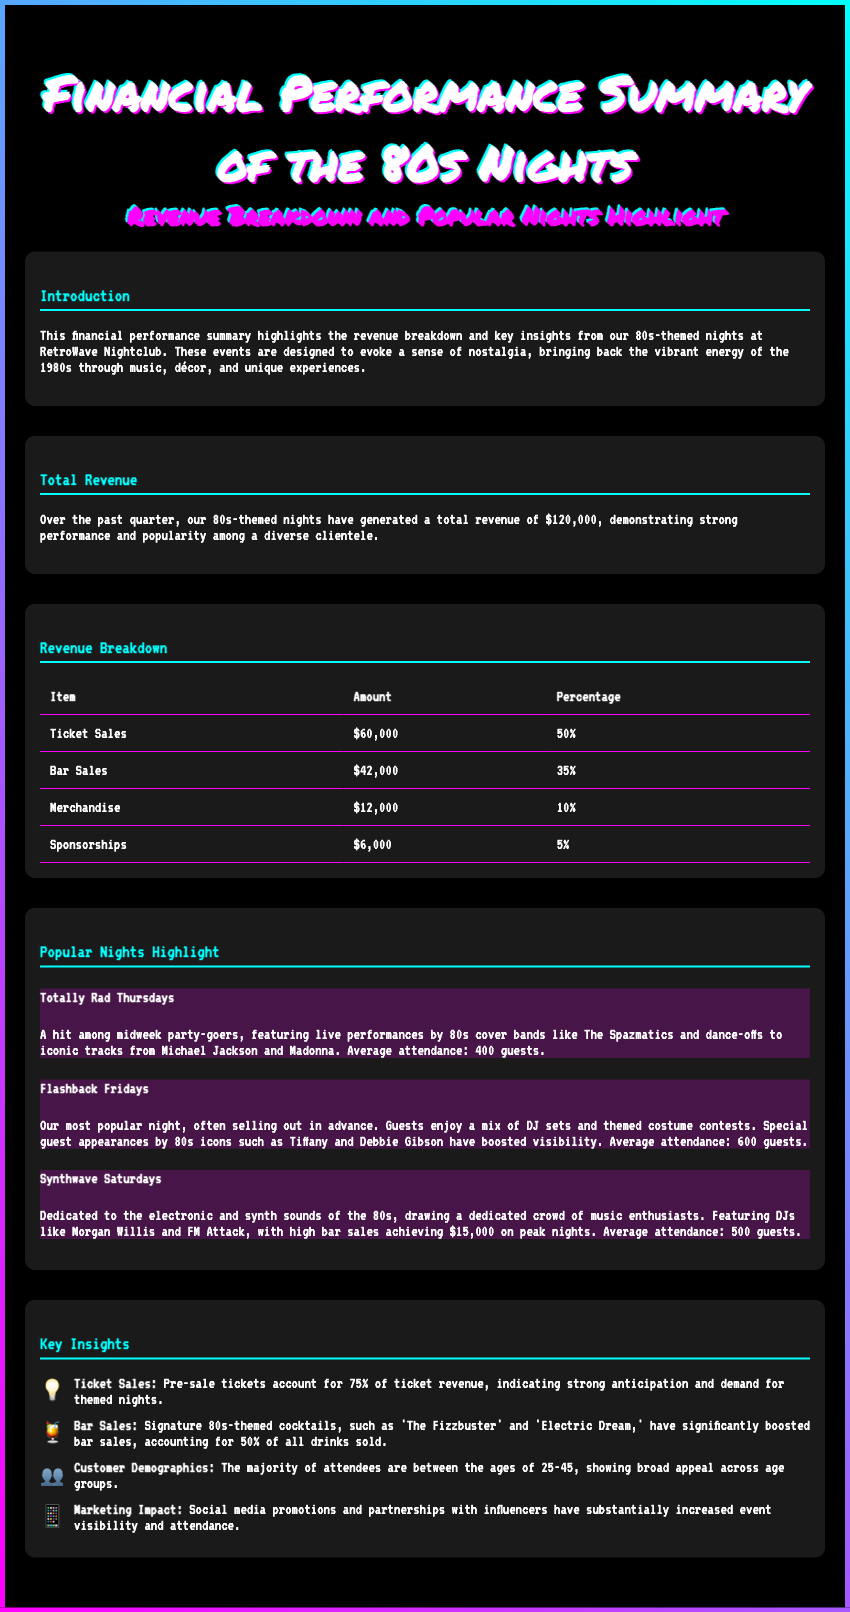What is the total revenue? The total revenue is stated as $120,000 in the document.
Answer: $120,000 What percentage of total revenue comes from ticket sales? The document indicates that ticket sales account for 50% of total revenue.
Answer: 50% How much did bar sales generate? Bar sales are reported to generate $42,000.
Answer: $42,000 Which night had the highest average attendance? Flashback Fridays is mentioned as having the highest average attendance of 600 guests.
Answer: 600 guests What percentage do pre-sale tickets account for ticket revenue? The document states that pre-sale tickets account for 75% of ticket revenue.
Answer: 75% What are the two signature cocktails mentioned? The document highlights 'The Fizzbuster' and 'Electric Dream' as signature cocktails.
Answer: The Fizzbuster and Electric Dream What is the main audience age range for the events? The majority of attendees are reported to be between 25-45 years old.
Answer: 25-45 Which event features live performances by 80s cover bands? Totally Rad Thursdays is mentioned as featuring live performances by 80s cover bands.
Answer: Totally Rad Thursdays What promotional method significantly increased visibility and attendance? The document states that social media promotions and partnerships with influencers had a substantial impact.
Answer: Social media promotions and partnerships with influencers 